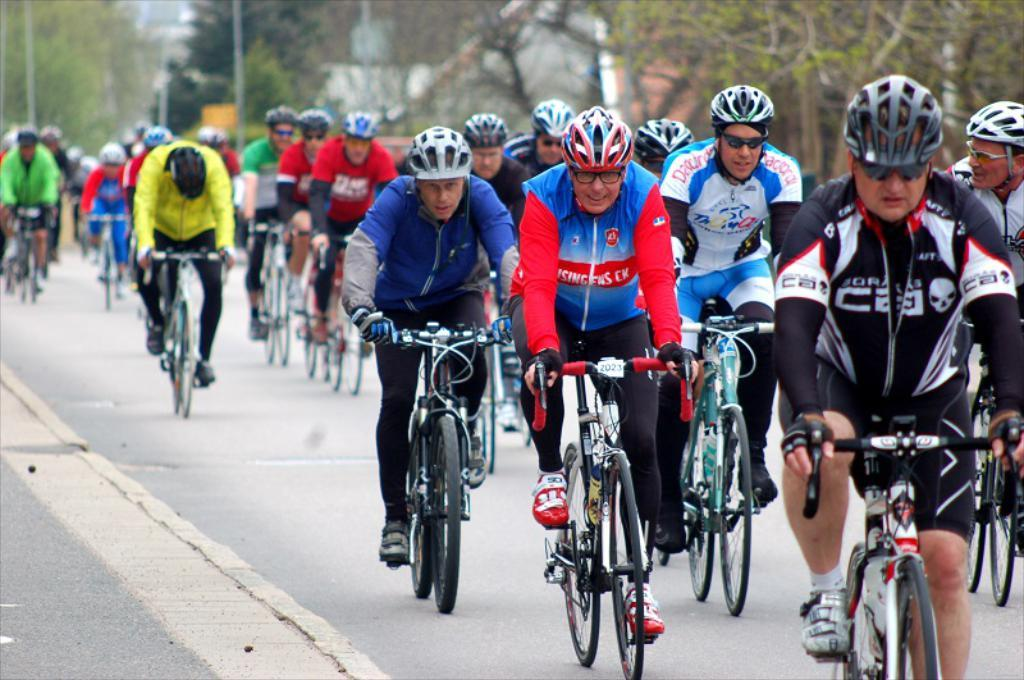Where was the image taken? The image is taken outdoors. What can be seen at the bottom of the image? There is a road at the bottom of the image. What is visible in the background of the image? There are many trees in the background of the image. What are the people in the image doing? Multiple people are riding bicycles in the middle of the image. What type of drum can be heard in the background of the image? There is no drum present in the image, and therefore no sound can be heard. 